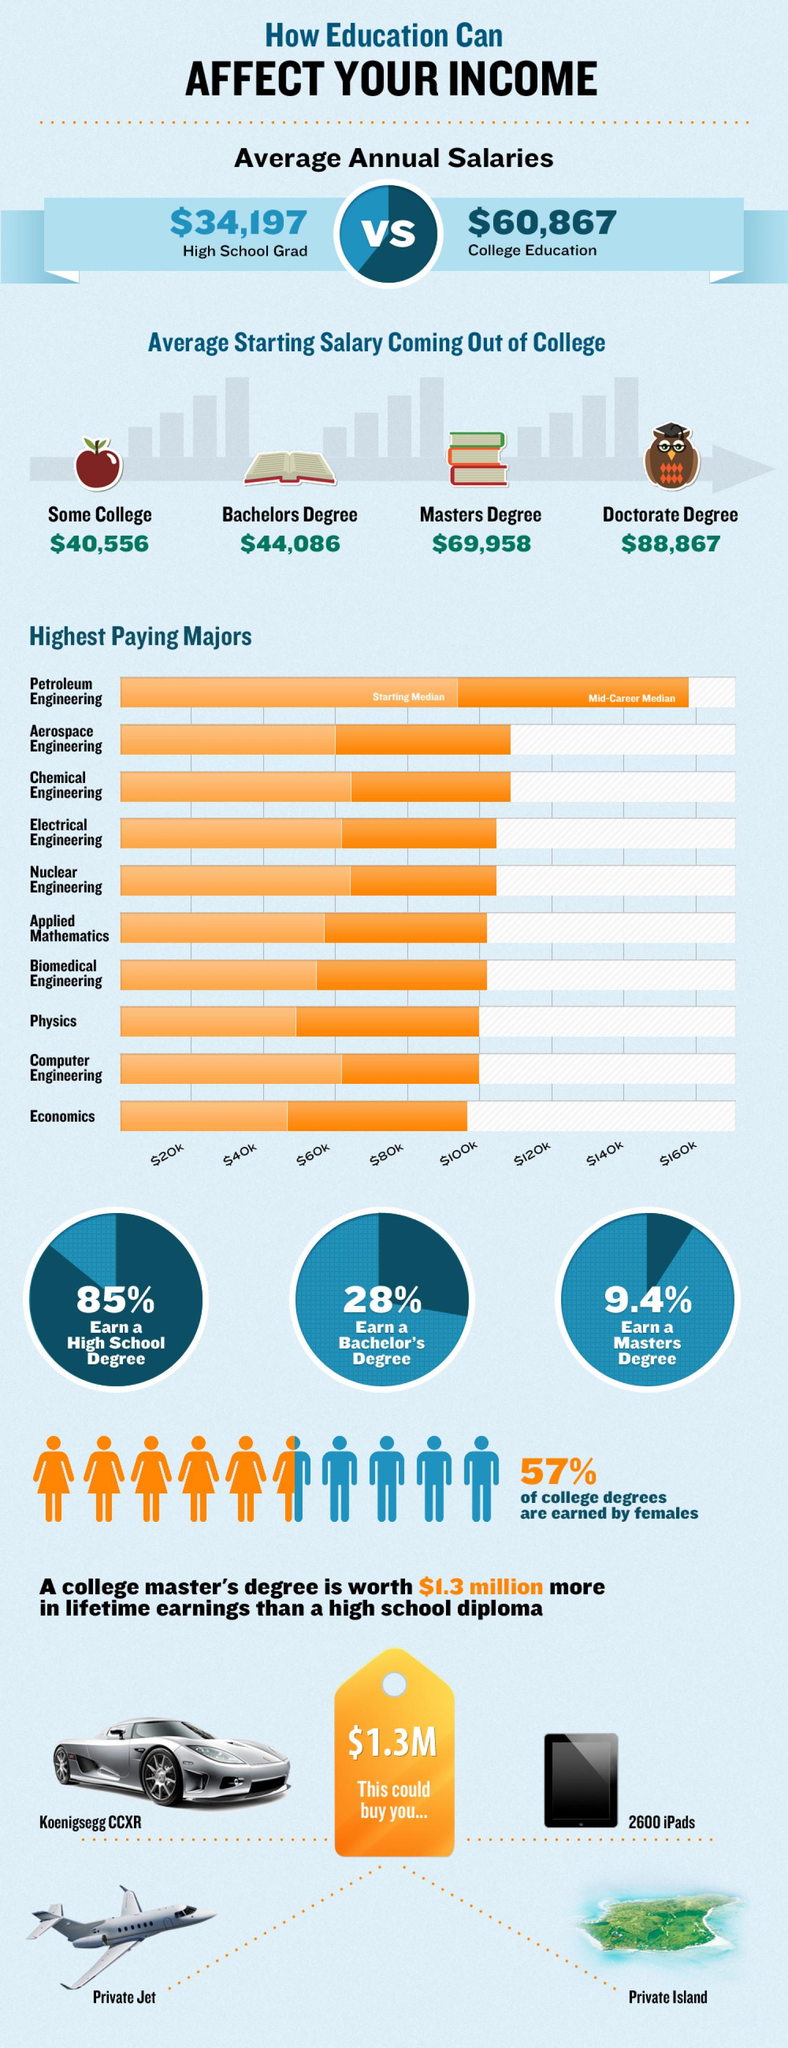Highlight a few significant elements in this photo. According to statistics, 85% of students successfully earn a high school diploma. Based on recent data, Aerospace Engineering is the second highest paid college major. According to a recent study, only 9.4% of students earn a master's degree. According to a recent study, 43% of all college degrees are earned by males. The average starting salary for freshers with a doctorate degree is $88,867. 